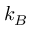<formula> <loc_0><loc_0><loc_500><loc_500>k _ { B }</formula> 